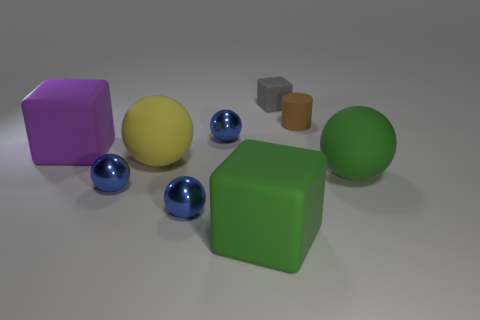There is a large rubber object behind the large yellow rubber thing; does it have the same shape as the green matte thing that is left of the big green sphere? Yes, the large rubber object positioned behind the large yellow one does indeed share the same cubic shape as the matte green object situated to the left of the big green sphere. Both objects exhibit the distinct edges and equal sides characteristic of a cube. 